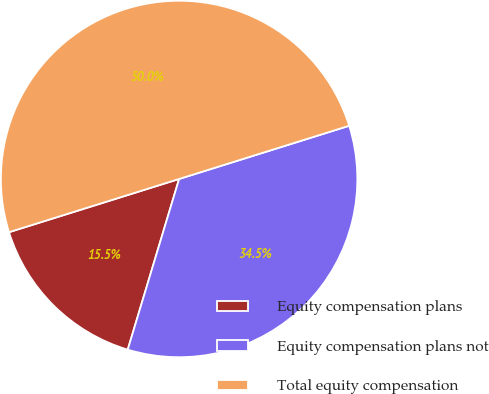Convert chart to OTSL. <chart><loc_0><loc_0><loc_500><loc_500><pie_chart><fcel>Equity compensation plans<fcel>Equity compensation plans not<fcel>Total equity compensation<nl><fcel>15.52%<fcel>34.48%<fcel>50.0%<nl></chart> 